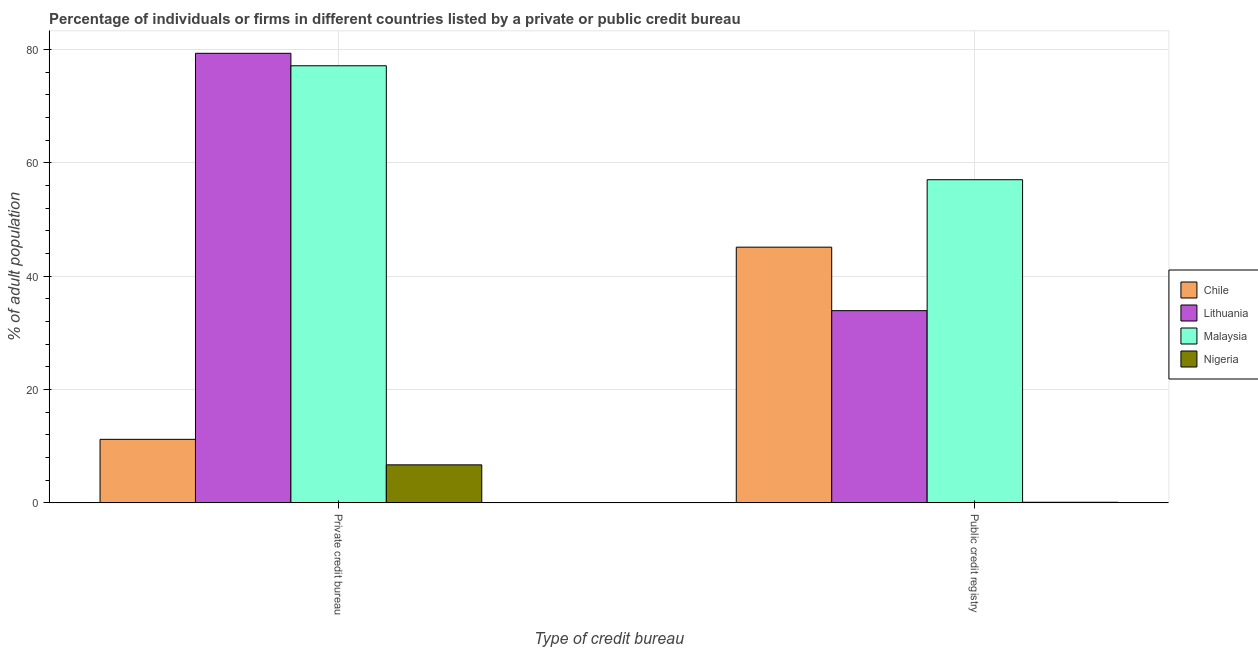How many different coloured bars are there?
Give a very brief answer. 4. How many groups of bars are there?
Your answer should be compact. 2. Are the number of bars per tick equal to the number of legend labels?
Keep it short and to the point. Yes. Are the number of bars on each tick of the X-axis equal?
Keep it short and to the point. Yes. How many bars are there on the 1st tick from the left?
Provide a short and direct response. 4. What is the label of the 2nd group of bars from the left?
Your response must be concise. Public credit registry. What is the percentage of firms listed by private credit bureau in Nigeria?
Make the answer very short. 6.7. Across all countries, what is the maximum percentage of firms listed by private credit bureau?
Provide a short and direct response. 79.3. In which country was the percentage of firms listed by public credit bureau maximum?
Provide a short and direct response. Malaysia. In which country was the percentage of firms listed by public credit bureau minimum?
Offer a terse response. Nigeria. What is the total percentage of firms listed by public credit bureau in the graph?
Provide a succinct answer. 136.1. What is the difference between the percentage of firms listed by public credit bureau in Chile and that in Nigeria?
Provide a succinct answer. 45. What is the difference between the percentage of firms listed by private credit bureau in Nigeria and the percentage of firms listed by public credit bureau in Malaysia?
Keep it short and to the point. -50.3. What is the average percentage of firms listed by private credit bureau per country?
Your response must be concise. 43.57. What is the difference between the percentage of firms listed by private credit bureau and percentage of firms listed by public credit bureau in Nigeria?
Your response must be concise. 6.6. What is the ratio of the percentage of firms listed by private credit bureau in Malaysia to that in Chile?
Offer a very short reply. 6.88. Is the percentage of firms listed by private credit bureau in Lithuania less than that in Nigeria?
Offer a very short reply. No. What does the 4th bar from the left in Private credit bureau represents?
Your answer should be compact. Nigeria. What does the 3rd bar from the right in Private credit bureau represents?
Your response must be concise. Lithuania. How many bars are there?
Ensure brevity in your answer.  8. Are all the bars in the graph horizontal?
Make the answer very short. No. What is the difference between two consecutive major ticks on the Y-axis?
Provide a succinct answer. 20. Are the values on the major ticks of Y-axis written in scientific E-notation?
Give a very brief answer. No. Does the graph contain any zero values?
Offer a very short reply. No. Does the graph contain grids?
Your answer should be compact. Yes. How are the legend labels stacked?
Your answer should be compact. Vertical. What is the title of the graph?
Make the answer very short. Percentage of individuals or firms in different countries listed by a private or public credit bureau. Does "Armenia" appear as one of the legend labels in the graph?
Your answer should be compact. No. What is the label or title of the X-axis?
Ensure brevity in your answer.  Type of credit bureau. What is the label or title of the Y-axis?
Your response must be concise. % of adult population. What is the % of adult population in Lithuania in Private credit bureau?
Provide a succinct answer. 79.3. What is the % of adult population in Malaysia in Private credit bureau?
Make the answer very short. 77.1. What is the % of adult population in Chile in Public credit registry?
Provide a short and direct response. 45.1. What is the % of adult population of Lithuania in Public credit registry?
Offer a terse response. 33.9. What is the % of adult population of Malaysia in Public credit registry?
Give a very brief answer. 57. What is the % of adult population of Nigeria in Public credit registry?
Give a very brief answer. 0.1. Across all Type of credit bureau, what is the maximum % of adult population in Chile?
Your answer should be compact. 45.1. Across all Type of credit bureau, what is the maximum % of adult population of Lithuania?
Ensure brevity in your answer.  79.3. Across all Type of credit bureau, what is the maximum % of adult population of Malaysia?
Give a very brief answer. 77.1. Across all Type of credit bureau, what is the minimum % of adult population of Chile?
Your response must be concise. 11.2. Across all Type of credit bureau, what is the minimum % of adult population of Lithuania?
Your response must be concise. 33.9. Across all Type of credit bureau, what is the minimum % of adult population of Malaysia?
Provide a short and direct response. 57. What is the total % of adult population of Chile in the graph?
Provide a succinct answer. 56.3. What is the total % of adult population in Lithuania in the graph?
Offer a terse response. 113.2. What is the total % of adult population of Malaysia in the graph?
Your response must be concise. 134.1. What is the total % of adult population of Nigeria in the graph?
Make the answer very short. 6.8. What is the difference between the % of adult population in Chile in Private credit bureau and that in Public credit registry?
Your response must be concise. -33.9. What is the difference between the % of adult population in Lithuania in Private credit bureau and that in Public credit registry?
Make the answer very short. 45.4. What is the difference between the % of adult population of Malaysia in Private credit bureau and that in Public credit registry?
Give a very brief answer. 20.1. What is the difference between the % of adult population of Nigeria in Private credit bureau and that in Public credit registry?
Provide a short and direct response. 6.6. What is the difference between the % of adult population in Chile in Private credit bureau and the % of adult population in Lithuania in Public credit registry?
Provide a succinct answer. -22.7. What is the difference between the % of adult population in Chile in Private credit bureau and the % of adult population in Malaysia in Public credit registry?
Your answer should be compact. -45.8. What is the difference between the % of adult population in Chile in Private credit bureau and the % of adult population in Nigeria in Public credit registry?
Give a very brief answer. 11.1. What is the difference between the % of adult population of Lithuania in Private credit bureau and the % of adult population of Malaysia in Public credit registry?
Keep it short and to the point. 22.3. What is the difference between the % of adult population of Lithuania in Private credit bureau and the % of adult population of Nigeria in Public credit registry?
Provide a short and direct response. 79.2. What is the difference between the % of adult population of Malaysia in Private credit bureau and the % of adult population of Nigeria in Public credit registry?
Your answer should be compact. 77. What is the average % of adult population in Chile per Type of credit bureau?
Provide a short and direct response. 28.15. What is the average % of adult population of Lithuania per Type of credit bureau?
Provide a short and direct response. 56.6. What is the average % of adult population in Malaysia per Type of credit bureau?
Your response must be concise. 67.05. What is the average % of adult population in Nigeria per Type of credit bureau?
Keep it short and to the point. 3.4. What is the difference between the % of adult population of Chile and % of adult population of Lithuania in Private credit bureau?
Give a very brief answer. -68.1. What is the difference between the % of adult population of Chile and % of adult population of Malaysia in Private credit bureau?
Make the answer very short. -65.9. What is the difference between the % of adult population of Chile and % of adult population of Nigeria in Private credit bureau?
Your answer should be compact. 4.5. What is the difference between the % of adult population in Lithuania and % of adult population in Malaysia in Private credit bureau?
Ensure brevity in your answer.  2.2. What is the difference between the % of adult population in Lithuania and % of adult population in Nigeria in Private credit bureau?
Keep it short and to the point. 72.6. What is the difference between the % of adult population of Malaysia and % of adult population of Nigeria in Private credit bureau?
Your response must be concise. 70.4. What is the difference between the % of adult population of Chile and % of adult population of Lithuania in Public credit registry?
Provide a succinct answer. 11.2. What is the difference between the % of adult population of Chile and % of adult population of Malaysia in Public credit registry?
Your response must be concise. -11.9. What is the difference between the % of adult population of Lithuania and % of adult population of Malaysia in Public credit registry?
Provide a succinct answer. -23.1. What is the difference between the % of adult population of Lithuania and % of adult population of Nigeria in Public credit registry?
Keep it short and to the point. 33.8. What is the difference between the % of adult population in Malaysia and % of adult population in Nigeria in Public credit registry?
Your response must be concise. 56.9. What is the ratio of the % of adult population of Chile in Private credit bureau to that in Public credit registry?
Make the answer very short. 0.25. What is the ratio of the % of adult population in Lithuania in Private credit bureau to that in Public credit registry?
Ensure brevity in your answer.  2.34. What is the ratio of the % of adult population in Malaysia in Private credit bureau to that in Public credit registry?
Give a very brief answer. 1.35. What is the difference between the highest and the second highest % of adult population in Chile?
Ensure brevity in your answer.  33.9. What is the difference between the highest and the second highest % of adult population of Lithuania?
Offer a terse response. 45.4. What is the difference between the highest and the second highest % of adult population of Malaysia?
Ensure brevity in your answer.  20.1. What is the difference between the highest and the second highest % of adult population of Nigeria?
Offer a very short reply. 6.6. What is the difference between the highest and the lowest % of adult population in Chile?
Make the answer very short. 33.9. What is the difference between the highest and the lowest % of adult population in Lithuania?
Provide a succinct answer. 45.4. What is the difference between the highest and the lowest % of adult population of Malaysia?
Offer a terse response. 20.1. 